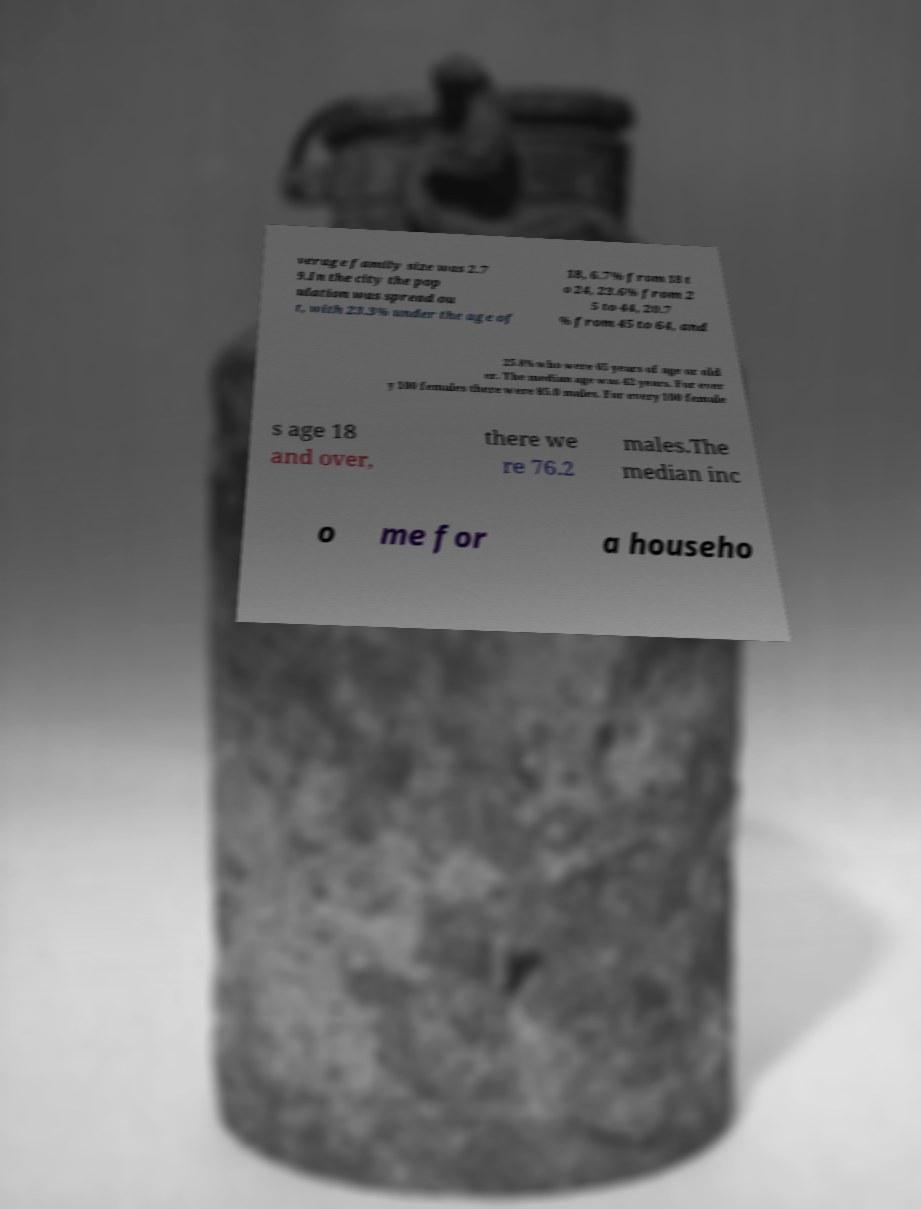Could you assist in decoding the text presented in this image and type it out clearly? verage family size was 2.7 9.In the city the pop ulation was spread ou t, with 23.3% under the age of 18, 6.7% from 18 t o 24, 23.6% from 2 5 to 44, 20.7 % from 45 to 64, and 25.8% who were 65 years of age or old er. The median age was 42 years. For ever y 100 females there were 85.0 males. For every 100 female s age 18 and over, there we re 76.2 males.The median inc o me for a househo 